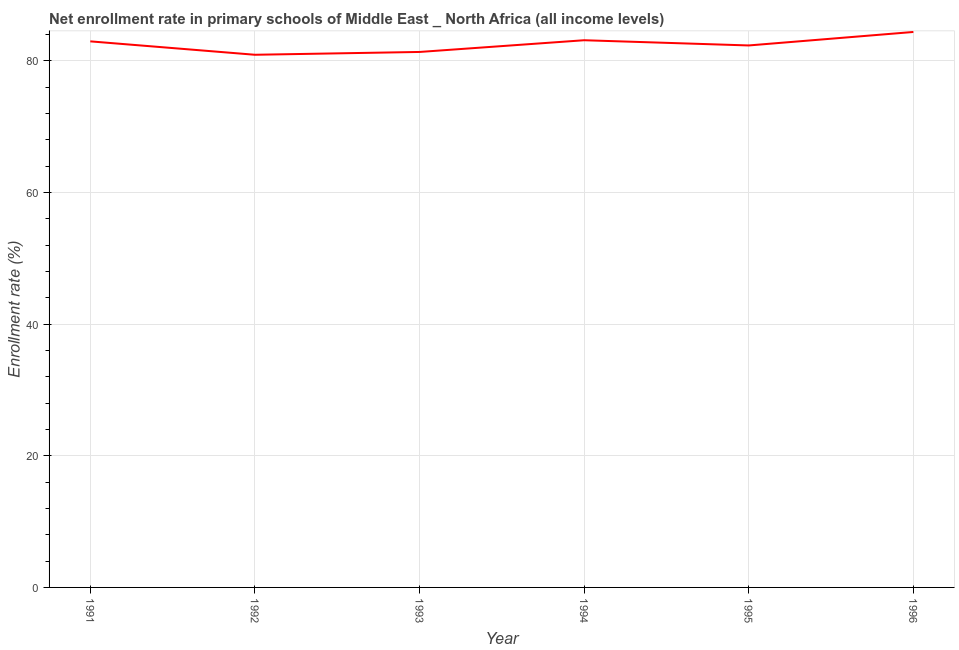What is the net enrollment rate in primary schools in 1994?
Ensure brevity in your answer.  83.14. Across all years, what is the maximum net enrollment rate in primary schools?
Offer a terse response. 84.4. Across all years, what is the minimum net enrollment rate in primary schools?
Your response must be concise. 80.93. In which year was the net enrollment rate in primary schools maximum?
Give a very brief answer. 1996. What is the sum of the net enrollment rate in primary schools?
Offer a terse response. 495.15. What is the difference between the net enrollment rate in primary schools in 1993 and 1995?
Ensure brevity in your answer.  -0.99. What is the average net enrollment rate in primary schools per year?
Ensure brevity in your answer.  82.53. What is the median net enrollment rate in primary schools?
Your answer should be compact. 82.66. In how many years, is the net enrollment rate in primary schools greater than 72 %?
Your answer should be compact. 6. Do a majority of the years between 1995 and 1992 (inclusive) have net enrollment rate in primary schools greater than 48 %?
Ensure brevity in your answer.  Yes. What is the ratio of the net enrollment rate in primary schools in 1991 to that in 1995?
Your answer should be very brief. 1.01. Is the net enrollment rate in primary schools in 1995 less than that in 1996?
Your answer should be very brief. Yes. Is the difference between the net enrollment rate in primary schools in 1992 and 1995 greater than the difference between any two years?
Provide a short and direct response. No. What is the difference between the highest and the second highest net enrollment rate in primary schools?
Give a very brief answer. 1.26. What is the difference between the highest and the lowest net enrollment rate in primary schools?
Ensure brevity in your answer.  3.46. How many years are there in the graph?
Your answer should be compact. 6. What is the title of the graph?
Make the answer very short. Net enrollment rate in primary schools of Middle East _ North Africa (all income levels). What is the label or title of the X-axis?
Give a very brief answer. Year. What is the label or title of the Y-axis?
Your response must be concise. Enrollment rate (%). What is the Enrollment rate (%) of 1991?
Your answer should be compact. 82.97. What is the Enrollment rate (%) of 1992?
Your answer should be very brief. 80.93. What is the Enrollment rate (%) in 1993?
Your answer should be very brief. 81.36. What is the Enrollment rate (%) in 1994?
Offer a very short reply. 83.14. What is the Enrollment rate (%) in 1995?
Your answer should be compact. 82.35. What is the Enrollment rate (%) in 1996?
Provide a succinct answer. 84.4. What is the difference between the Enrollment rate (%) in 1991 and 1992?
Provide a succinct answer. 2.04. What is the difference between the Enrollment rate (%) in 1991 and 1993?
Provide a short and direct response. 1.61. What is the difference between the Enrollment rate (%) in 1991 and 1994?
Ensure brevity in your answer.  -0.17. What is the difference between the Enrollment rate (%) in 1991 and 1995?
Your response must be concise. 0.62. What is the difference between the Enrollment rate (%) in 1991 and 1996?
Provide a short and direct response. -1.43. What is the difference between the Enrollment rate (%) in 1992 and 1993?
Provide a short and direct response. -0.43. What is the difference between the Enrollment rate (%) in 1992 and 1994?
Your answer should be compact. -2.21. What is the difference between the Enrollment rate (%) in 1992 and 1995?
Ensure brevity in your answer.  -1.42. What is the difference between the Enrollment rate (%) in 1992 and 1996?
Make the answer very short. -3.46. What is the difference between the Enrollment rate (%) in 1993 and 1994?
Your response must be concise. -1.78. What is the difference between the Enrollment rate (%) in 1993 and 1995?
Keep it short and to the point. -0.99. What is the difference between the Enrollment rate (%) in 1993 and 1996?
Your answer should be very brief. -3.04. What is the difference between the Enrollment rate (%) in 1994 and 1995?
Your answer should be very brief. 0.79. What is the difference between the Enrollment rate (%) in 1994 and 1996?
Ensure brevity in your answer.  -1.26. What is the difference between the Enrollment rate (%) in 1995 and 1996?
Your answer should be compact. -2.05. What is the ratio of the Enrollment rate (%) in 1991 to that in 1992?
Make the answer very short. 1.02. What is the ratio of the Enrollment rate (%) in 1991 to that in 1993?
Provide a succinct answer. 1.02. What is the ratio of the Enrollment rate (%) in 1991 to that in 1995?
Give a very brief answer. 1.01. What is the ratio of the Enrollment rate (%) in 1991 to that in 1996?
Keep it short and to the point. 0.98. What is the ratio of the Enrollment rate (%) in 1992 to that in 1993?
Make the answer very short. 0.99. What is the ratio of the Enrollment rate (%) in 1992 to that in 1995?
Make the answer very short. 0.98. What is the ratio of the Enrollment rate (%) in 1992 to that in 1996?
Give a very brief answer. 0.96. What is the ratio of the Enrollment rate (%) in 1993 to that in 1996?
Your answer should be compact. 0.96. What is the ratio of the Enrollment rate (%) in 1995 to that in 1996?
Provide a short and direct response. 0.98. 